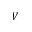Convert formula to latex. <formula><loc_0><loc_0><loc_500><loc_500>V</formula> 